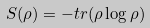<formula> <loc_0><loc_0><loc_500><loc_500>S ( \rho ) = - t r ( \rho \log \rho )</formula> 